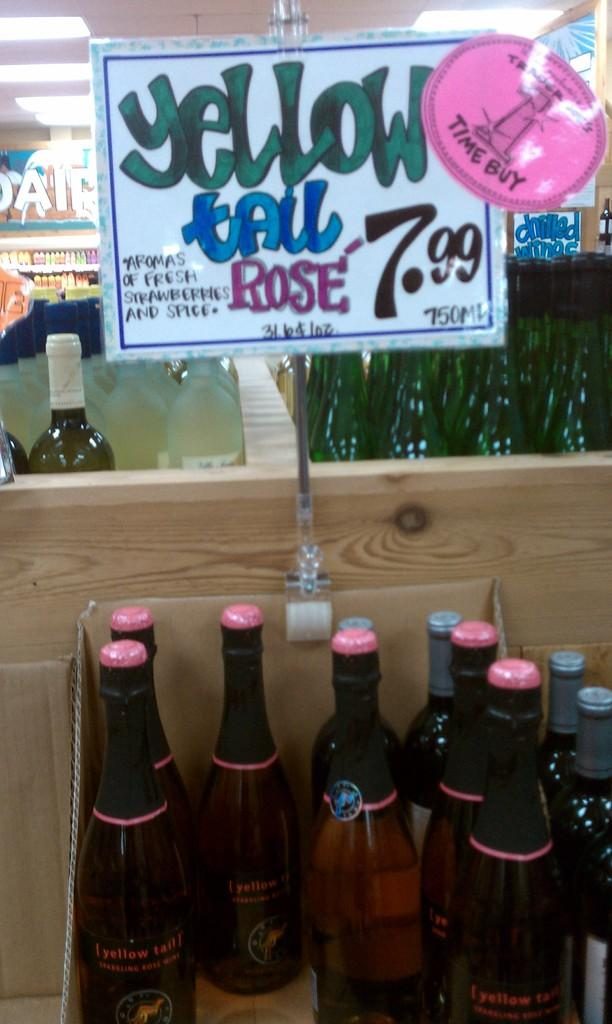<image>
Offer a succinct explanation of the picture presented. Bottles under a sign which says Yellow tail rose. 